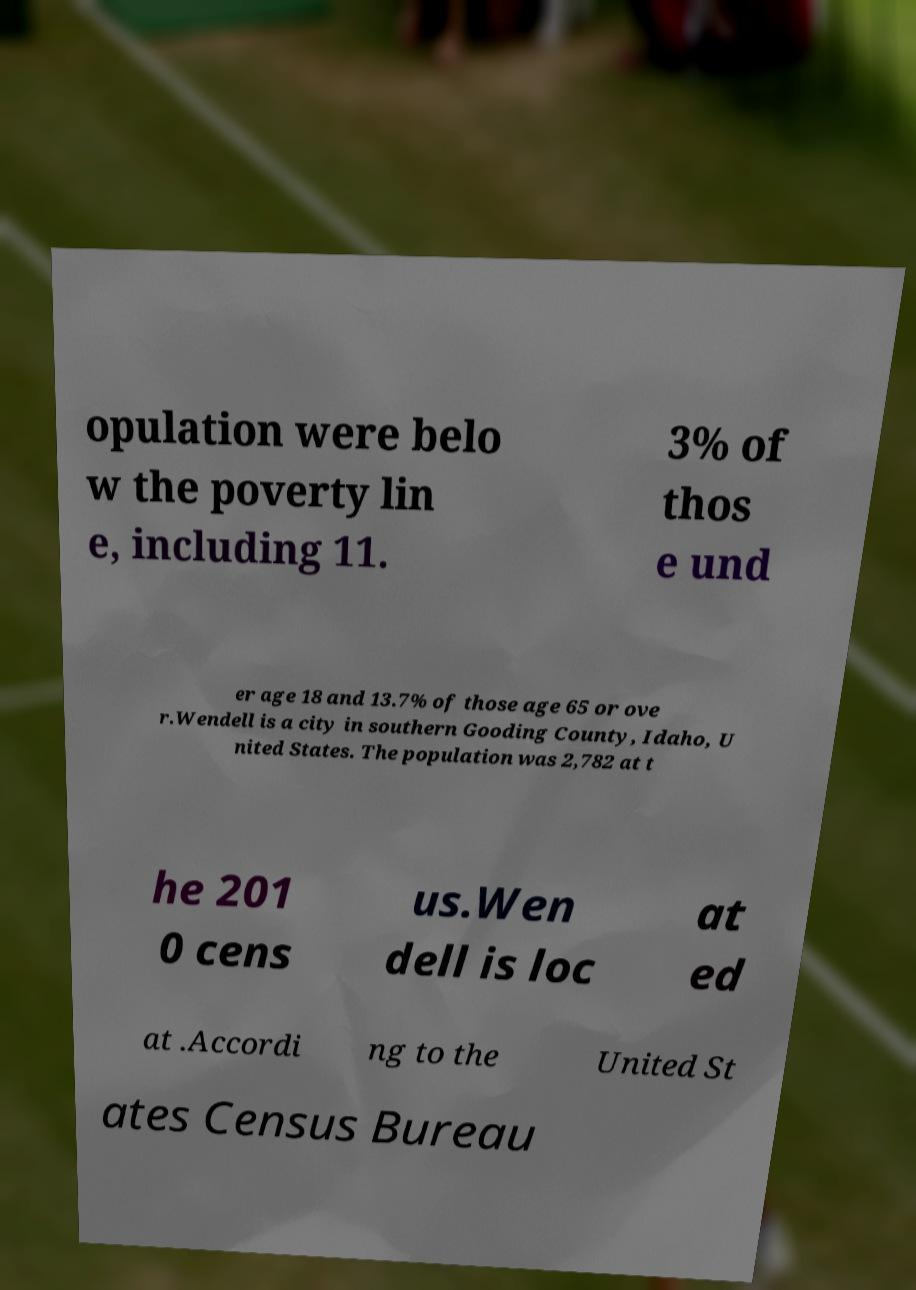Can you read and provide the text displayed in the image?This photo seems to have some interesting text. Can you extract and type it out for me? opulation were belo w the poverty lin e, including 11. 3% of thos e und er age 18 and 13.7% of those age 65 or ove r.Wendell is a city in southern Gooding County, Idaho, U nited States. The population was 2,782 at t he 201 0 cens us.Wen dell is loc at ed at .Accordi ng to the United St ates Census Bureau 